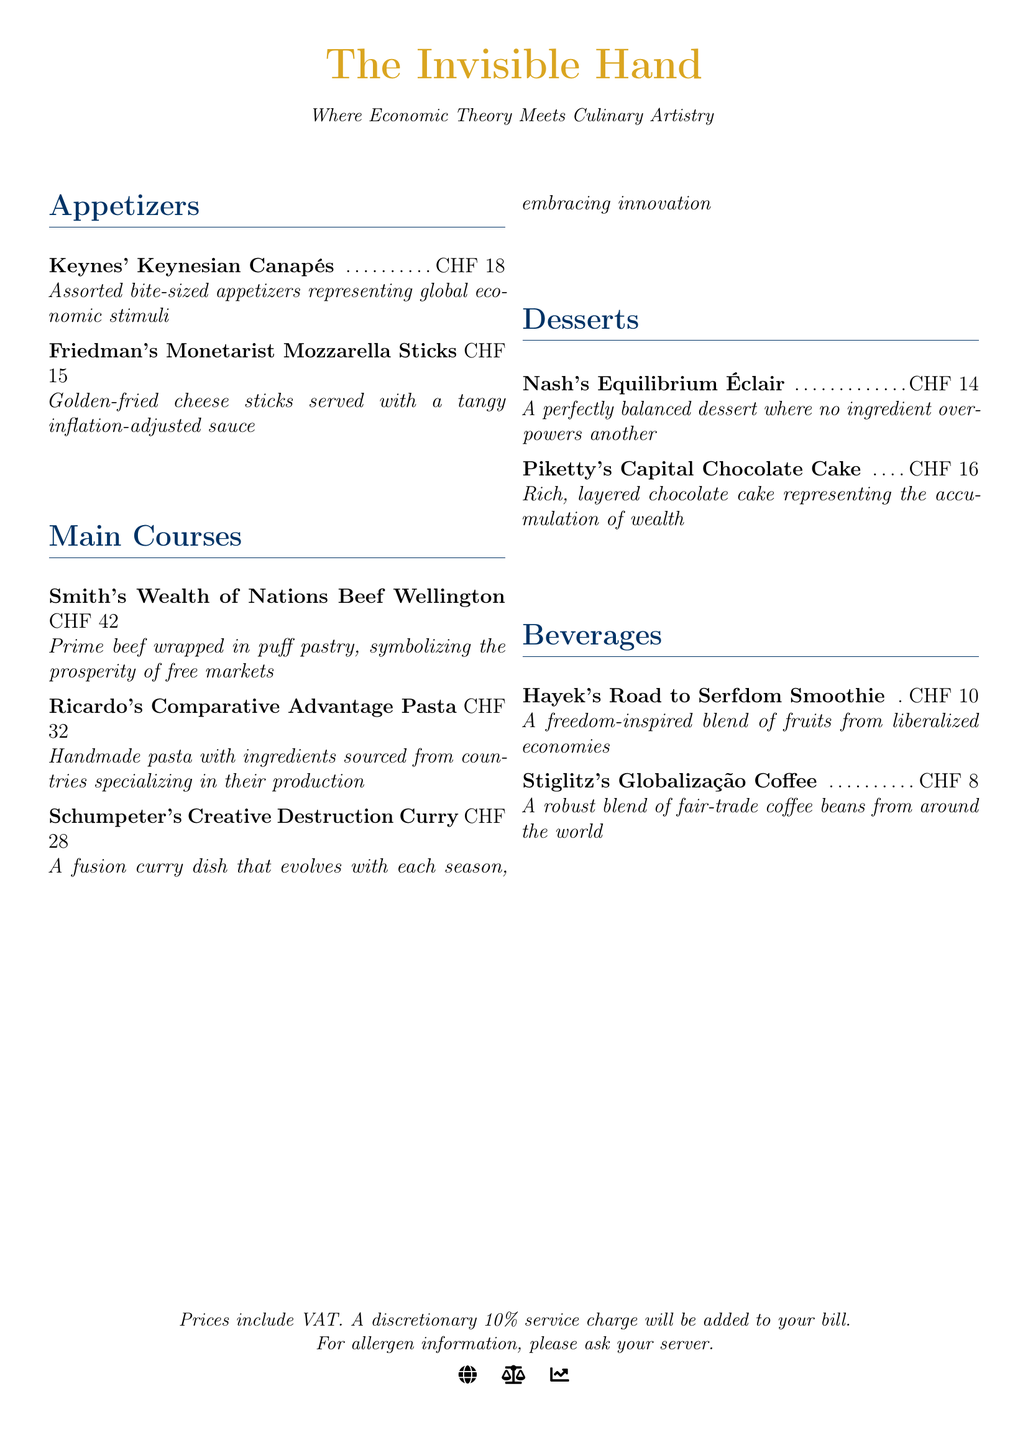What is the price of Keynes' Keynesian Canapés? The price of Keynes' Keynesian Canapés is listed in the appetizers section of the menu.
Answer: CHF 18 Which dish is named after Schumpeter? The dish named after Schumpeter in the main courses section is identified by its unique title.
Answer: Schumpeter's Creative Destruction Curry How much do the Friedman's Monetarist Mozzarella Sticks cost? The price is found directly next to the dish name in the appetizers section.
Answer: CHF 15 What kind of dessert is Nash's Equilibrium Éclair? A clarification about the nature or concept behind the dessert can be inferred from its description.
Answer: A perfectly balanced dessert Which beverage features Hayek's name? The beverage named after Hayek can be identified in the beverages section of the menu.
Answer: Hayek's Road to Serfdom Smoothie What is the total number of appetizers listed? The quantity of appetizers can be determined by counting the menu items in that section.
Answer: 2 What characteristic defines Piketty's Capital Chocolate Cake? The defining feature of Piketty's dish can be derived from its description in the menu.
Answer: Rich, layered chocolate cake How many main courses are on the menu? The total number of main courses is simply counted from that section of the menu.
Answer: 3 What is the price of Stiglitz's Globalização Coffee? The cost is stated next to the beverage name in the menu.
Answer: CHF 8 